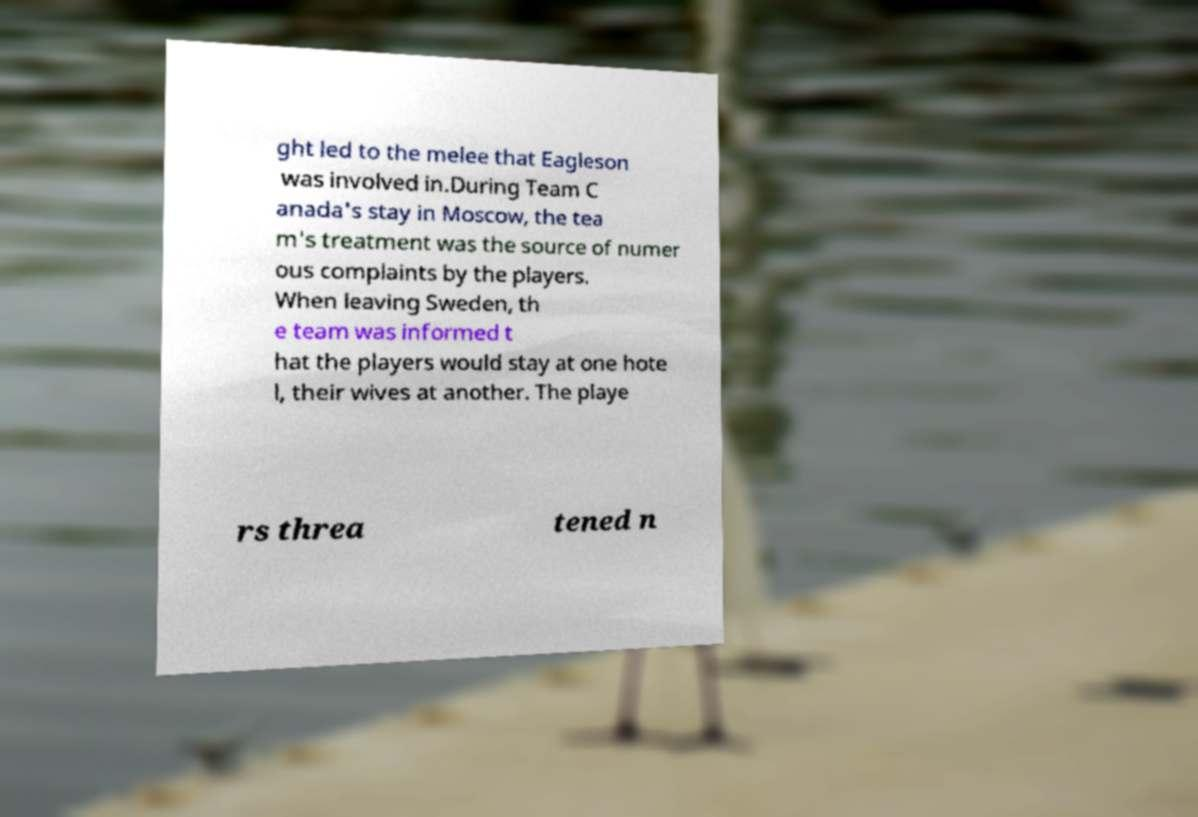Can you accurately transcribe the text from the provided image for me? ght led to the melee that Eagleson was involved in.During Team C anada's stay in Moscow, the tea m's treatment was the source of numer ous complaints by the players. When leaving Sweden, th e team was informed t hat the players would stay at one hote l, their wives at another. The playe rs threa tened n 